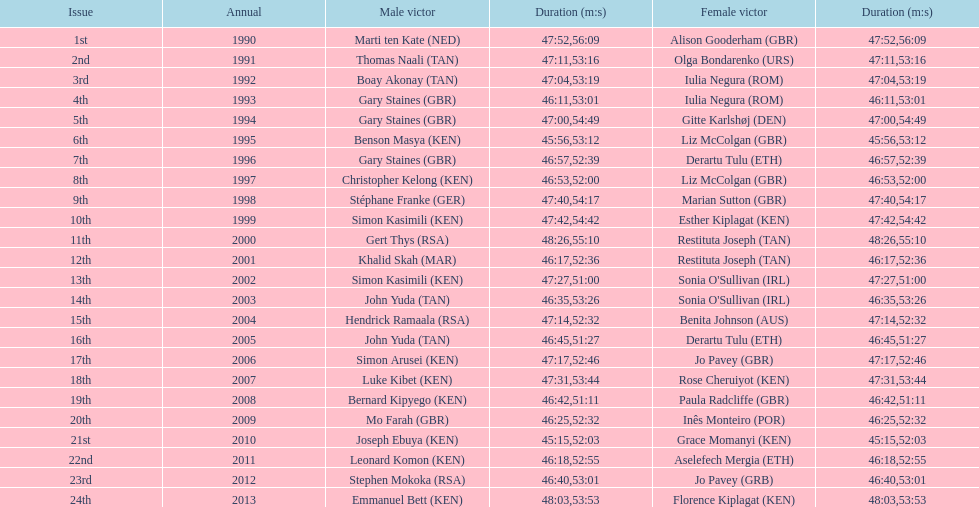Parse the table in full. {'header': ['Issue', 'Annual', 'Male victor', 'Duration (m:s)', 'Female victor', 'Duration (m:s)'], 'rows': [['1st', '1990', 'Marti ten Kate\xa0(NED)', '47:52', 'Alison Gooderham\xa0(GBR)', '56:09'], ['2nd', '1991', 'Thomas Naali\xa0(TAN)', '47:11', 'Olga Bondarenko\xa0(URS)', '53:16'], ['3rd', '1992', 'Boay Akonay\xa0(TAN)', '47:04', 'Iulia Negura\xa0(ROM)', '53:19'], ['4th', '1993', 'Gary Staines\xa0(GBR)', '46:11', 'Iulia Negura\xa0(ROM)', '53:01'], ['5th', '1994', 'Gary Staines\xa0(GBR)', '47:00', 'Gitte Karlshøj\xa0(DEN)', '54:49'], ['6th', '1995', 'Benson Masya\xa0(KEN)', '45:56', 'Liz McColgan\xa0(GBR)', '53:12'], ['7th', '1996', 'Gary Staines\xa0(GBR)', '46:57', 'Derartu Tulu\xa0(ETH)', '52:39'], ['8th', '1997', 'Christopher Kelong\xa0(KEN)', '46:53', 'Liz McColgan\xa0(GBR)', '52:00'], ['9th', '1998', 'Stéphane Franke\xa0(GER)', '47:40', 'Marian Sutton\xa0(GBR)', '54:17'], ['10th', '1999', 'Simon Kasimili\xa0(KEN)', '47:42', 'Esther Kiplagat\xa0(KEN)', '54:42'], ['11th', '2000', 'Gert Thys\xa0(RSA)', '48:26', 'Restituta Joseph\xa0(TAN)', '55:10'], ['12th', '2001', 'Khalid Skah\xa0(MAR)', '46:17', 'Restituta Joseph\xa0(TAN)', '52:36'], ['13th', '2002', 'Simon Kasimili\xa0(KEN)', '47:27', "Sonia O'Sullivan\xa0(IRL)", '51:00'], ['14th', '2003', 'John Yuda\xa0(TAN)', '46:35', "Sonia O'Sullivan\xa0(IRL)", '53:26'], ['15th', '2004', 'Hendrick Ramaala\xa0(RSA)', '47:14', 'Benita Johnson\xa0(AUS)', '52:32'], ['16th', '2005', 'John Yuda\xa0(TAN)', '46:45', 'Derartu Tulu\xa0(ETH)', '51:27'], ['17th', '2006', 'Simon Arusei\xa0(KEN)', '47:17', 'Jo Pavey\xa0(GBR)', '52:46'], ['18th', '2007', 'Luke Kibet\xa0(KEN)', '47:31', 'Rose Cheruiyot\xa0(KEN)', '53:44'], ['19th', '2008', 'Bernard Kipyego\xa0(KEN)', '46:42', 'Paula Radcliffe\xa0(GBR)', '51:11'], ['20th', '2009', 'Mo Farah\xa0(GBR)', '46:25', 'Inês Monteiro\xa0(POR)', '52:32'], ['21st', '2010', 'Joseph Ebuya\xa0(KEN)', '45:15', 'Grace Momanyi\xa0(KEN)', '52:03'], ['22nd', '2011', 'Leonard Komon\xa0(KEN)', '46:18', 'Aselefech Mergia\xa0(ETH)', '52:55'], ['23rd', '2012', 'Stephen Mokoka\xa0(RSA)', '46:40', 'Jo Pavey\xa0(GRB)', '53:01'], ['24th', '2013', 'Emmanuel Bett\xa0(KEN)', '48:03', 'Florence Kiplagat\xa0(KEN)', '53:53']]} How long did sonia o'sullivan take to finish in 2003? 53:26. 